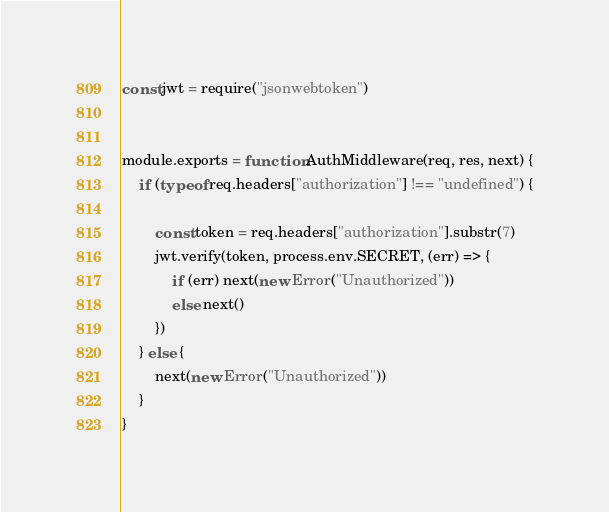<code> <loc_0><loc_0><loc_500><loc_500><_JavaScript_>const jwt = require("jsonwebtoken")


module.exports = function AuthMiddleware(req, res, next) {
    if (typeof req.headers["authorization"] !== "undefined") {

        const token = req.headers["authorization"].substr(7)
        jwt.verify(token, process.env.SECRET, (err) => {
            if (err) next(new Error("Unauthorized"))
            else next()
        })
    } else {
        next(new Error("Unauthorized"))
    }
}</code> 